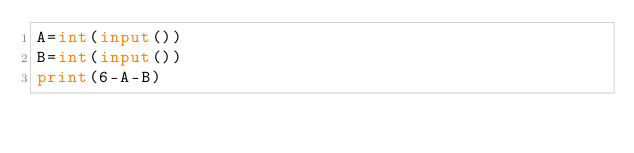<code> <loc_0><loc_0><loc_500><loc_500><_Python_>A=int(input())
B=int(input())
print(6-A-B)</code> 